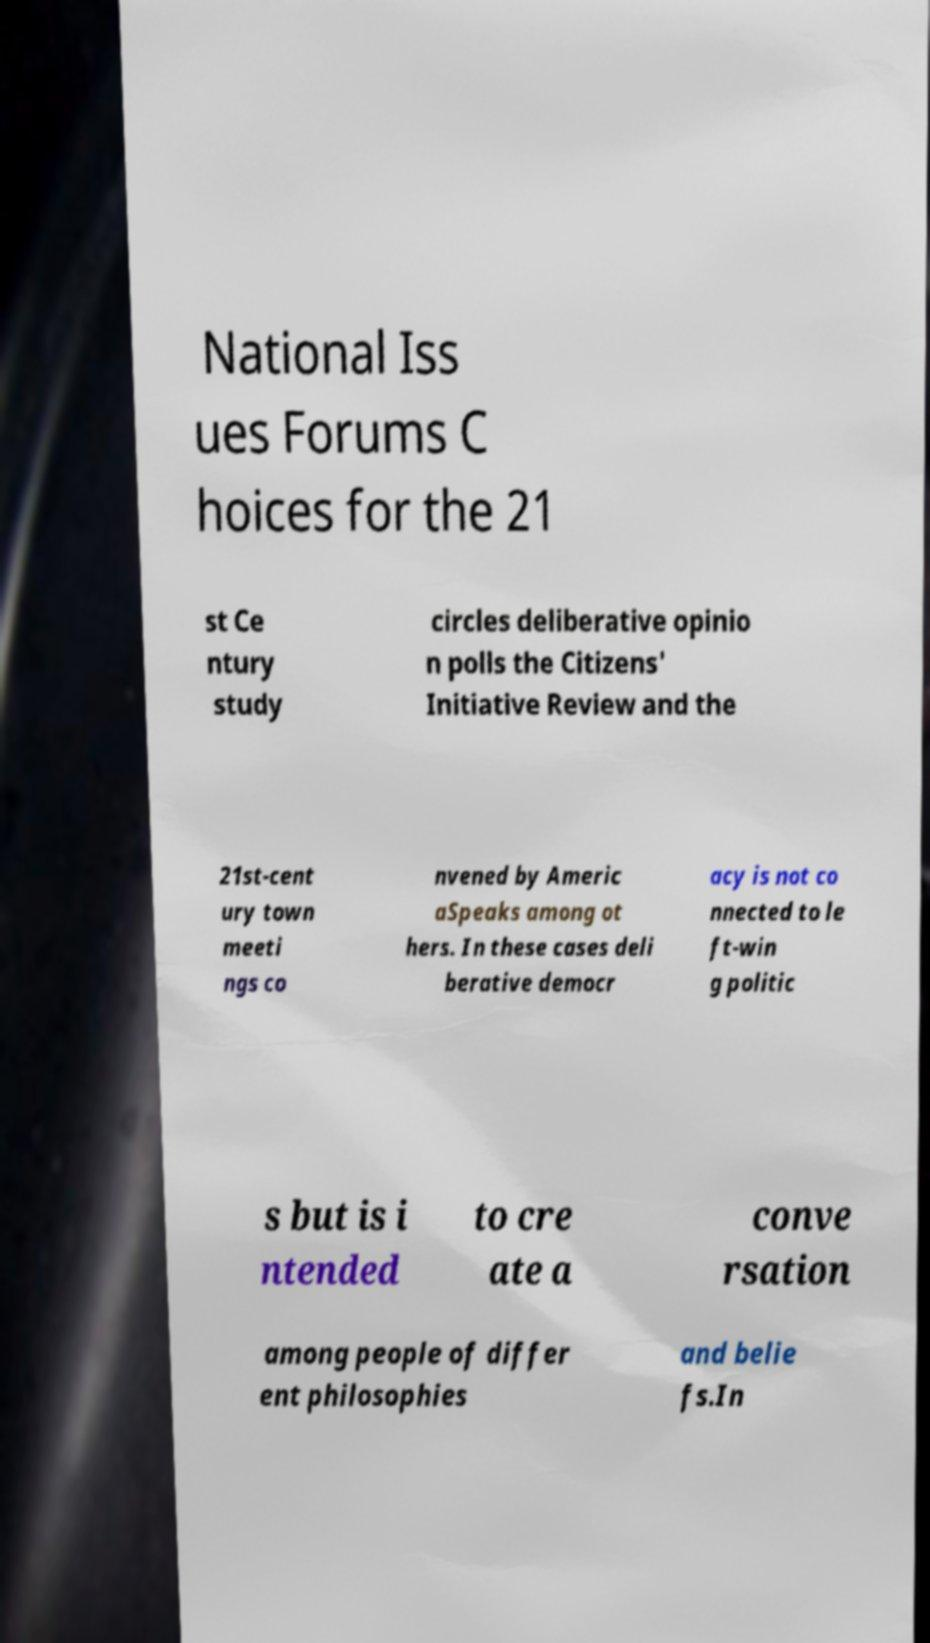There's text embedded in this image that I need extracted. Can you transcribe it verbatim? National Iss ues Forums C hoices for the 21 st Ce ntury study circles deliberative opinio n polls the Citizens' Initiative Review and the 21st-cent ury town meeti ngs co nvened by Americ aSpeaks among ot hers. In these cases deli berative democr acy is not co nnected to le ft-win g politic s but is i ntended to cre ate a conve rsation among people of differ ent philosophies and belie fs.In 